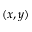<formula> <loc_0><loc_0><loc_500><loc_500>( x , y )</formula> 